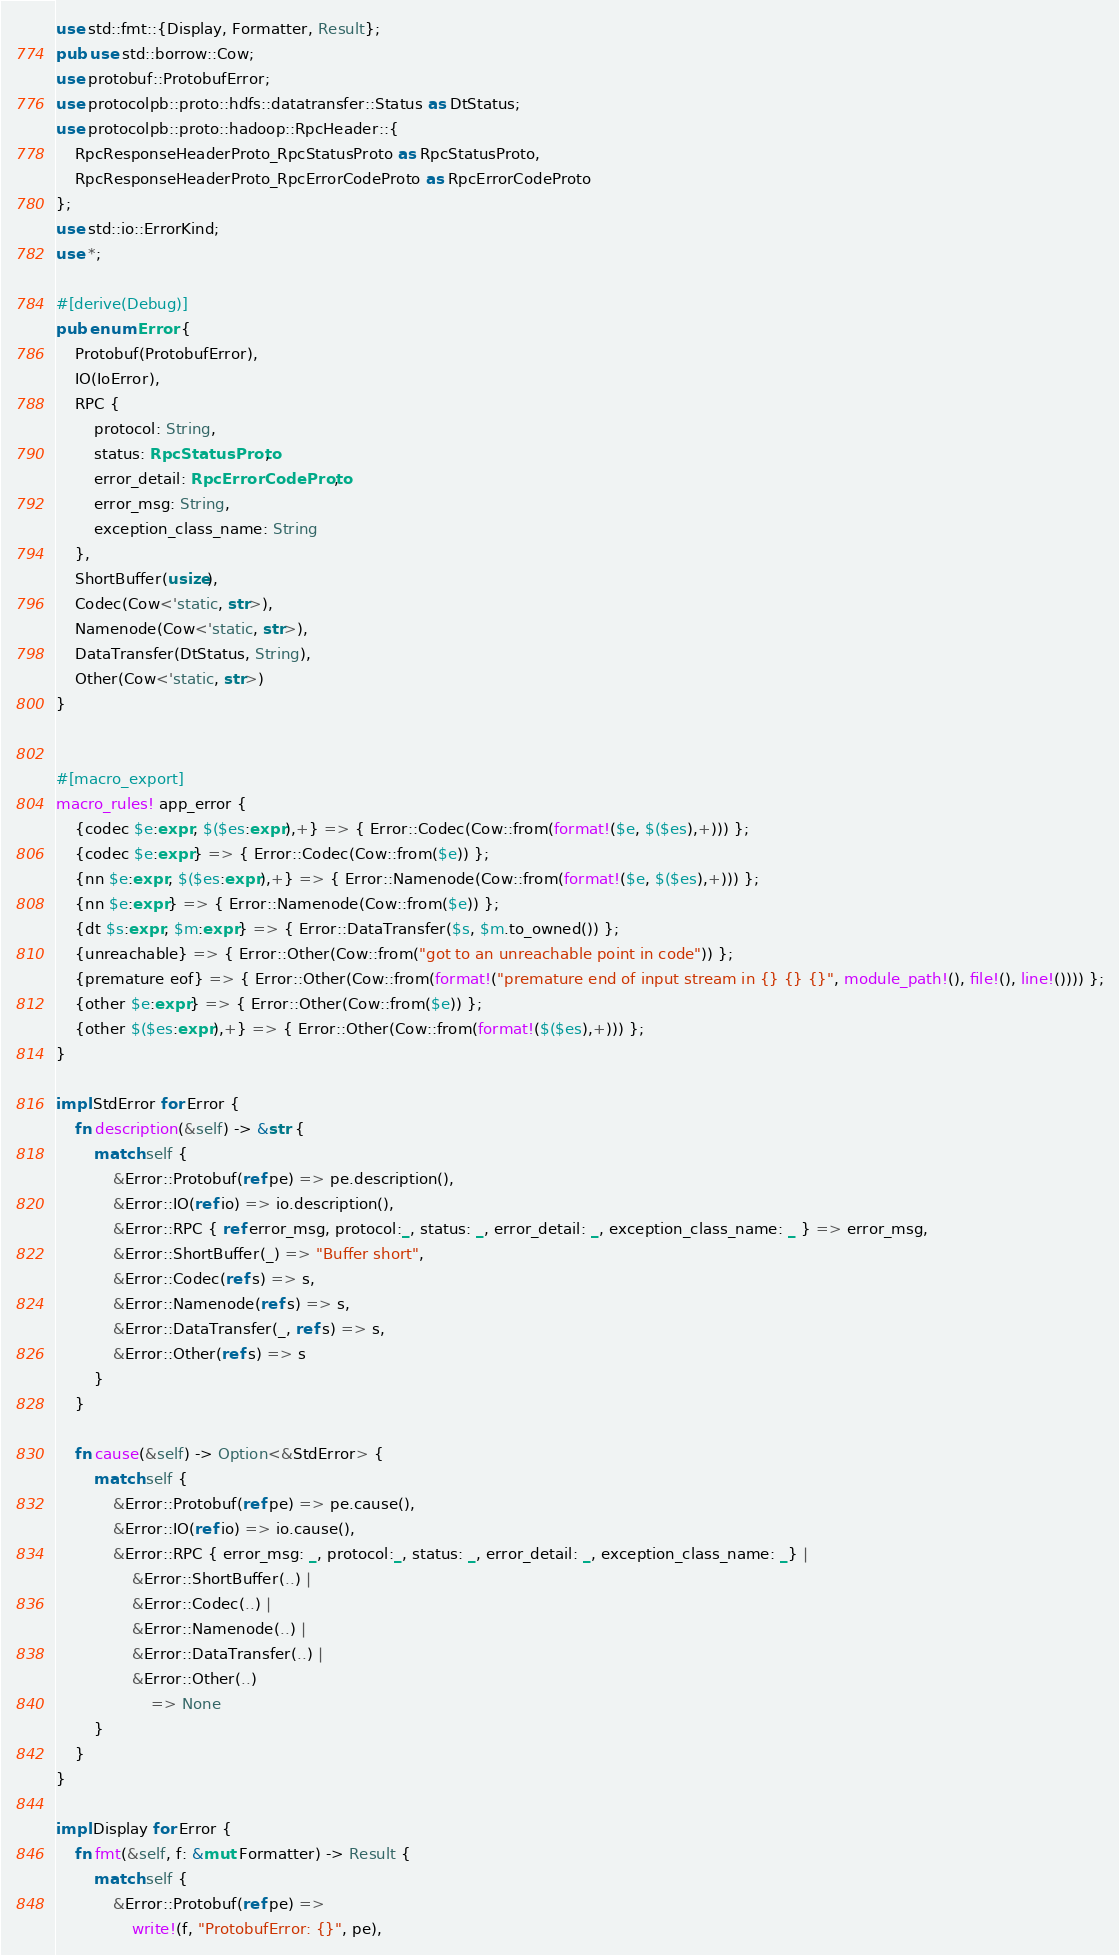<code> <loc_0><loc_0><loc_500><loc_500><_Rust_>
use std::fmt::{Display, Formatter, Result};
pub use std::borrow::Cow;
use protobuf::ProtobufError;
use protocolpb::proto::hdfs::datatransfer::Status as DtStatus;
use protocolpb::proto::hadoop::RpcHeader::{
    RpcResponseHeaderProto_RpcStatusProto as RpcStatusProto,
    RpcResponseHeaderProto_RpcErrorCodeProto as RpcErrorCodeProto
};
use std::io::ErrorKind;
use *;

#[derive(Debug)]
pub enum Error {
    Protobuf(ProtobufError),
    IO(IoError),
    RPC {
        protocol: String,
        status: RpcStatusProto,
        error_detail: RpcErrorCodeProto,
        error_msg: String,
        exception_class_name: String
    },
    ShortBuffer(usize),
    Codec(Cow<'static, str>),
    Namenode(Cow<'static, str>),
    DataTransfer(DtStatus, String),
    Other(Cow<'static, str>)
}


#[macro_export]
macro_rules! app_error {
    {codec $e:expr, $($es:expr),+} => { Error::Codec(Cow::from(format!($e, $($es),+))) };
    {codec $e:expr} => { Error::Codec(Cow::from($e)) };
    {nn $e:expr, $($es:expr),+} => { Error::Namenode(Cow::from(format!($e, $($es),+))) };
    {nn $e:expr} => { Error::Namenode(Cow::from($e)) };
    {dt $s:expr, $m:expr} => { Error::DataTransfer($s, $m.to_owned()) };
    {unreachable} => { Error::Other(Cow::from("got to an unreachable point in code")) };
    {premature eof} => { Error::Other(Cow::from(format!("premature end of input stream in {} {} {}", module_path!(), file!(), line!()))) };
    {other $e:expr} => { Error::Other(Cow::from($e)) };
    {other $($es:expr),+} => { Error::Other(Cow::from(format!($($es),+))) };
}

impl StdError for Error {
    fn description(&self) -> &str {
        match self {
            &Error::Protobuf(ref pe) => pe.description(),
            &Error::IO(ref io) => io.description(),
            &Error::RPC { ref error_msg, protocol:_, status: _, error_detail: _, exception_class_name: _ } => error_msg,
            &Error::ShortBuffer(_) => "Buffer short",
            &Error::Codec(ref s) => s,
            &Error::Namenode(ref s) => s,
            &Error::DataTransfer(_, ref s) => s,
            &Error::Other(ref s) => s
        }
    }

    fn cause(&self) -> Option<&StdError> {
        match self {
            &Error::Protobuf(ref pe) => pe.cause(),
            &Error::IO(ref io) => io.cause(),
            &Error::RPC { error_msg: _, protocol:_, status: _, error_detail: _, exception_class_name: _} |
                &Error::ShortBuffer(..) |
                &Error::Codec(..) |
                &Error::Namenode(..) |
                &Error::DataTransfer(..) |
                &Error::Other(..)
                    => None
        }
    }
}

impl Display for Error {
    fn fmt(&self, f: &mut Formatter) -> Result {
        match self {
            &Error::Protobuf(ref pe) =>
                write!(f, "ProtobufError: {}", pe),</code> 